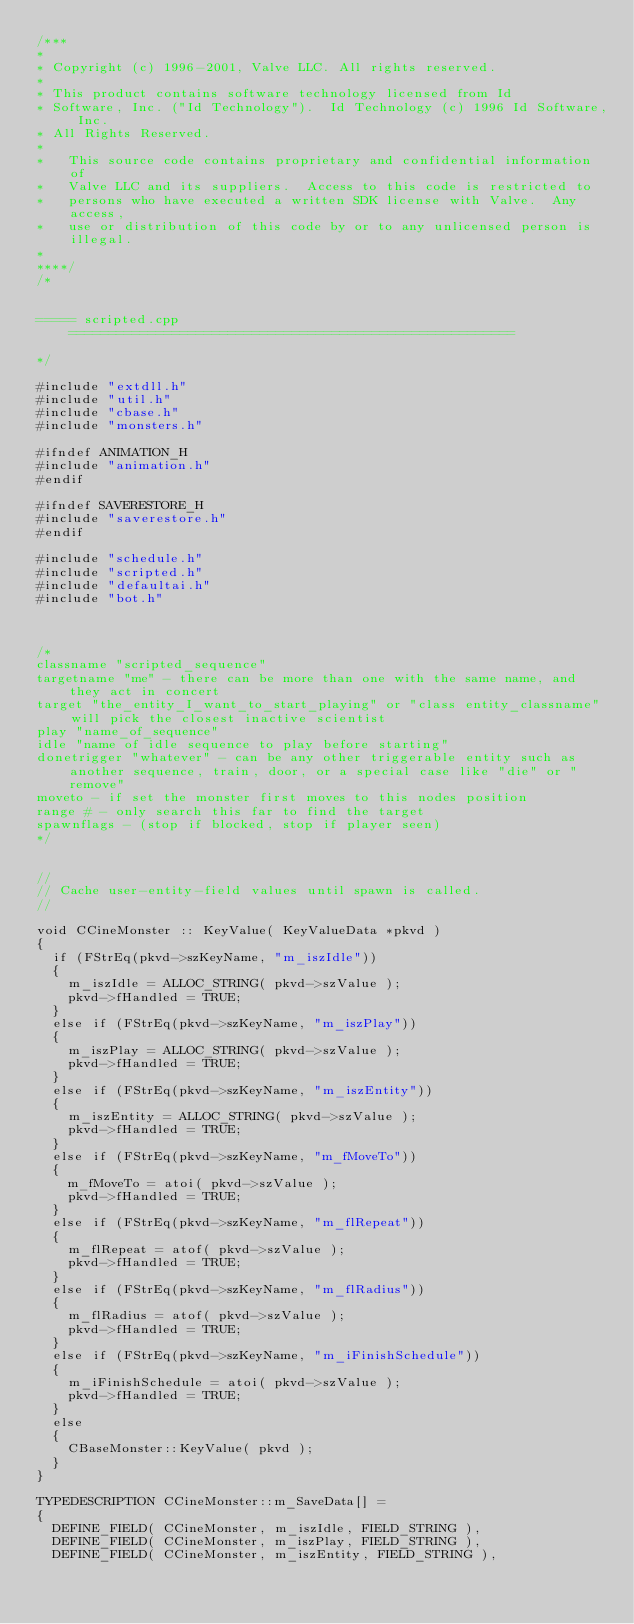<code> <loc_0><loc_0><loc_500><loc_500><_C++_>/***
*
*	Copyright (c) 1996-2001, Valve LLC. All rights reserved.
*	
*	This product contains software technology licensed from Id 
*	Software, Inc. ("Id Technology").  Id Technology (c) 1996 Id Software, Inc. 
*	All Rights Reserved.
*
*   This source code contains proprietary and confidential information of
*   Valve LLC and its suppliers.  Access to this code is restricted to
*   persons who have executed a written SDK license with Valve.  Any access,
*   use or distribution of this code by or to any unlicensed person is illegal.
*
****/
/*


===== scripted.cpp ========================================================

*/

#include "extdll.h"
#include "util.h"
#include "cbase.h"
#include "monsters.h"

#ifndef ANIMATION_H
#include "animation.h"
#endif

#ifndef SAVERESTORE_H
#include "saverestore.h"
#endif

#include "schedule.h"
#include "scripted.h"
#include "defaultai.h"
#include "bot.h"



/*
classname "scripted_sequence"
targetname "me" - there can be more than one with the same name, and they act in concert
target "the_entity_I_want_to_start_playing" or "class entity_classname" will pick the closest inactive scientist
play "name_of_sequence"
idle "name of idle sequence to play before starting"
donetrigger "whatever" - can be any other triggerable entity such as another sequence, train, door, or a special case like "die" or "remove"
moveto - if set the monster first moves to this nodes position
range # - only search this far to find the target
spawnflags - (stop if blocked, stop if player seen)
*/


//
// Cache user-entity-field values until spawn is called.
//

void CCineMonster :: KeyValue( KeyValueData *pkvd )
{
	if (FStrEq(pkvd->szKeyName, "m_iszIdle"))
	{
		m_iszIdle = ALLOC_STRING( pkvd->szValue );
		pkvd->fHandled = TRUE;
	}
	else if (FStrEq(pkvd->szKeyName, "m_iszPlay"))
	{
		m_iszPlay = ALLOC_STRING( pkvd->szValue );
		pkvd->fHandled = TRUE;
	}
	else if (FStrEq(pkvd->szKeyName, "m_iszEntity"))
	{
		m_iszEntity = ALLOC_STRING( pkvd->szValue );
		pkvd->fHandled = TRUE;
	}
	else if (FStrEq(pkvd->szKeyName, "m_fMoveTo"))
	{
		m_fMoveTo = atoi( pkvd->szValue );
		pkvd->fHandled = TRUE;
	}
	else if (FStrEq(pkvd->szKeyName, "m_flRepeat"))
	{
		m_flRepeat = atof( pkvd->szValue );
		pkvd->fHandled = TRUE;
	}
	else if (FStrEq(pkvd->szKeyName, "m_flRadius"))
	{
		m_flRadius = atof( pkvd->szValue );
		pkvd->fHandled = TRUE;
	}
	else if (FStrEq(pkvd->szKeyName, "m_iFinishSchedule"))
	{
		m_iFinishSchedule = atoi( pkvd->szValue );
		pkvd->fHandled = TRUE;
	}
	else
	{
		CBaseMonster::KeyValue( pkvd );
	}
}

TYPEDESCRIPTION	CCineMonster::m_SaveData[] = 
{
	DEFINE_FIELD( CCineMonster, m_iszIdle, FIELD_STRING ),
	DEFINE_FIELD( CCineMonster, m_iszPlay, FIELD_STRING ),
	DEFINE_FIELD( CCineMonster, m_iszEntity, FIELD_STRING ),</code> 